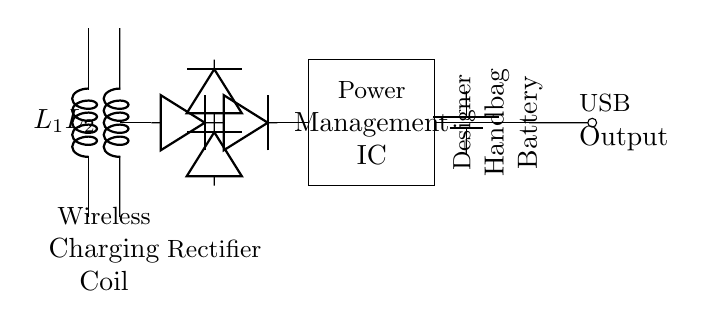What components are used for wireless charging? The circuit includes two inductors labeled L1 and L2, which form a wireless charging coil, needed to generate a magnetic field for wireless energy transfer.
Answer: L1, L2 What does the rectangular block represent? The rectangle labeled as "Power Management IC" shows the component that regulates the power flow to ensure efficient charging and discharging of the battery.
Answer: Power Management IC How many diodes are present in the rectifier section? Counting the diodes in the rectifier section, there are four diodes indicated in the circuit. Each diode allows current to pass in one direction, converting AC to DC.
Answer: 4 What is the output type for charging devices? The output type is indicated by the USB output, which shows a standard connection to charge mobile devices or power other devices.
Answer: USB Output What is the purpose of the battery in this circuit? The battery, labeled as "Designer Handbag Battery," stores the electrical energy received from wireless charging; it powers devices when the handbag is in use.
Answer: Stores energy Which component connects the battery to the USB output? The connection is made from the battery to the USB output through the output from the Power Management IC, facilitating the transfer of stored energy.
Answer: Power Management IC 